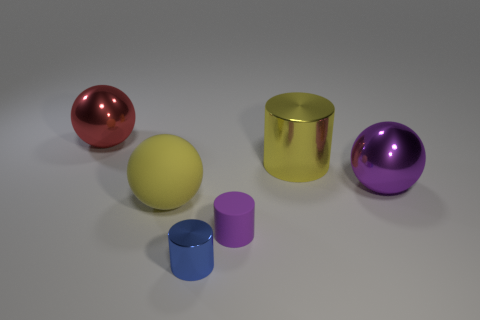There is a big yellow object that is in front of the large purple metallic ball; does it have the same shape as the red thing?
Make the answer very short. Yes. What material is the thing that is the same color as the rubber sphere?
Your answer should be very brief. Metal. What number of rubber things have the same color as the big cylinder?
Your response must be concise. 1. What is the shape of the yellow thing in front of the big metallic thing on the right side of the big yellow shiny cylinder?
Your answer should be very brief. Sphere. Are there any other matte things that have the same shape as the large rubber object?
Offer a very short reply. No. There is a tiny metal cylinder; is it the same color as the tiny cylinder to the right of the tiny blue object?
Your response must be concise. No. What size is the matte sphere that is the same color as the large shiny cylinder?
Keep it short and to the point. Large. Is there a purple metal object that has the same size as the blue cylinder?
Give a very brief answer. No. Is the large yellow ball made of the same material as the big sphere that is behind the large purple metal thing?
Keep it short and to the point. No. Is the number of metal objects greater than the number of big spheres?
Keep it short and to the point. Yes. 